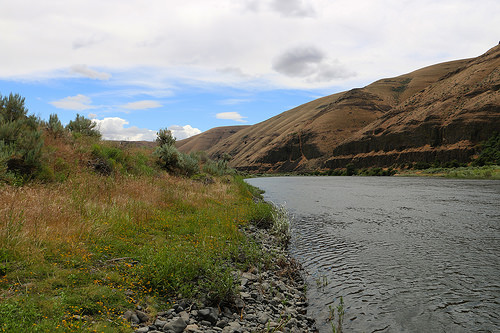<image>
Is there a cloud above the lake? Yes. The cloud is positioned above the lake in the vertical space, higher up in the scene. 